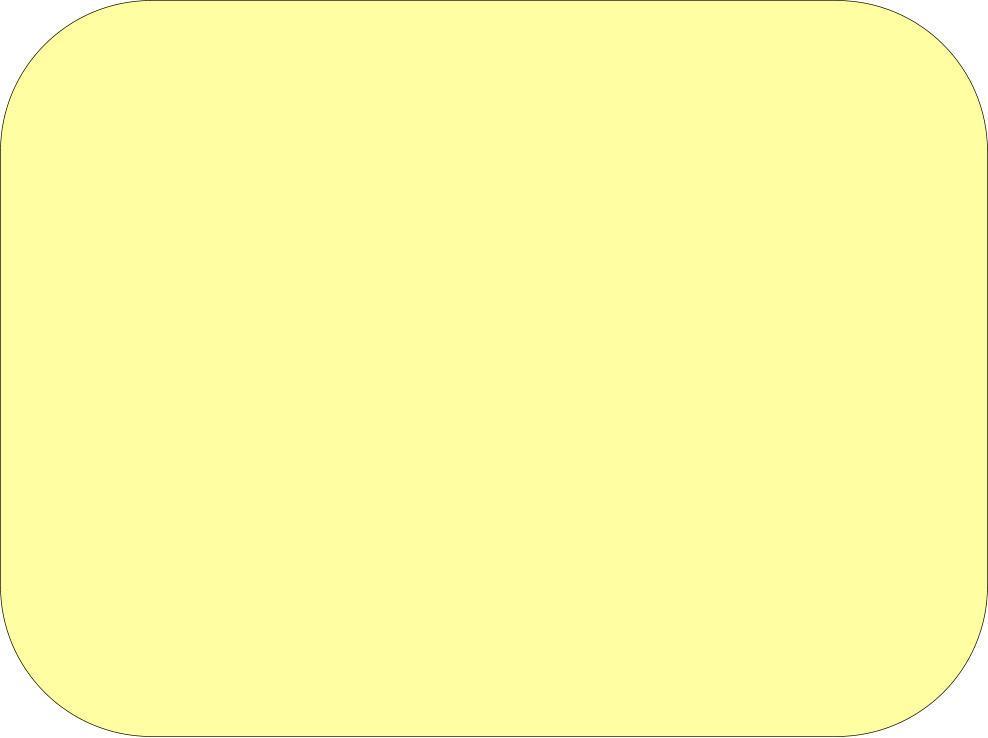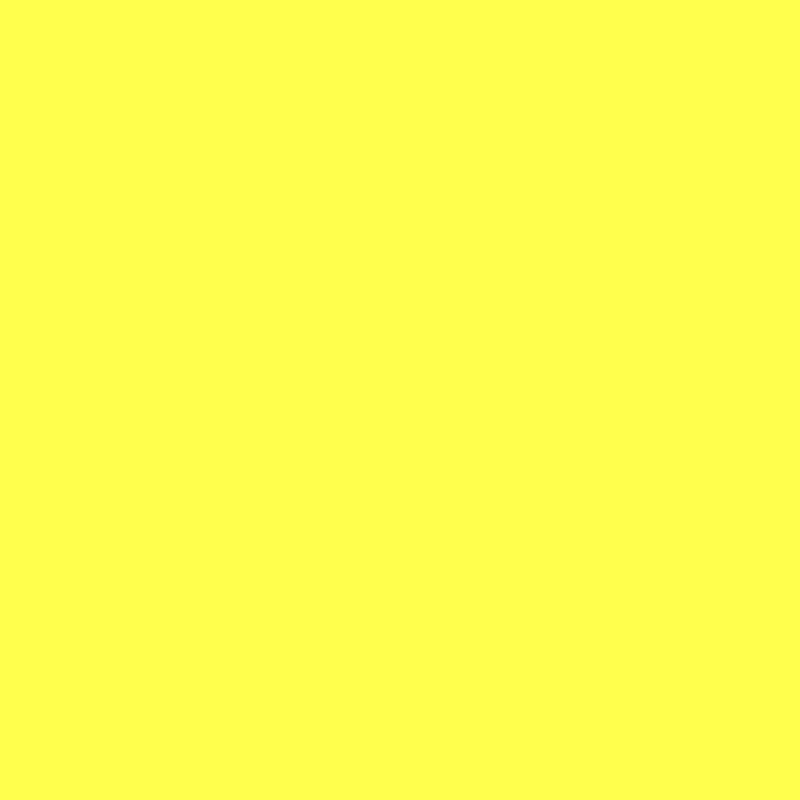The first image is the image on the left, the second image is the image on the right. For the images shown, is this caption "One or more of the photos depict yellow-orange powder arranged in a mound." true? Answer yes or no. No. The first image is the image on the left, the second image is the image on the right. Evaluate the accuracy of this statement regarding the images: "An image shows a mostly round pile of golden-yellow powder.". Is it true? Answer yes or no. No. 